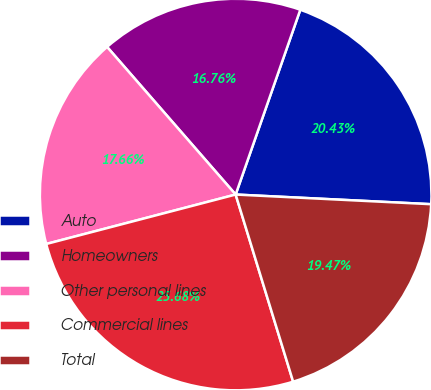Convert chart to OTSL. <chart><loc_0><loc_0><loc_500><loc_500><pie_chart><fcel>Auto<fcel>Homeowners<fcel>Other personal lines<fcel>Commercial lines<fcel>Total<nl><fcel>20.43%<fcel>16.76%<fcel>17.66%<fcel>25.68%<fcel>19.47%<nl></chart> 